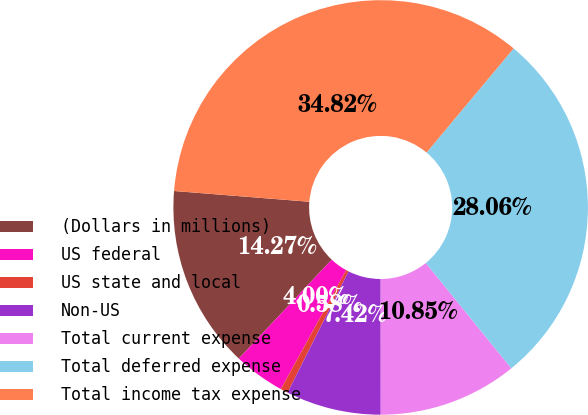Convert chart to OTSL. <chart><loc_0><loc_0><loc_500><loc_500><pie_chart><fcel>(Dollars in millions)<fcel>US federal<fcel>US state and local<fcel>Non-US<fcel>Total current expense<fcel>Total deferred expense<fcel>Total income tax expense<nl><fcel>14.27%<fcel>4.0%<fcel>0.58%<fcel>7.42%<fcel>10.85%<fcel>28.06%<fcel>34.82%<nl></chart> 